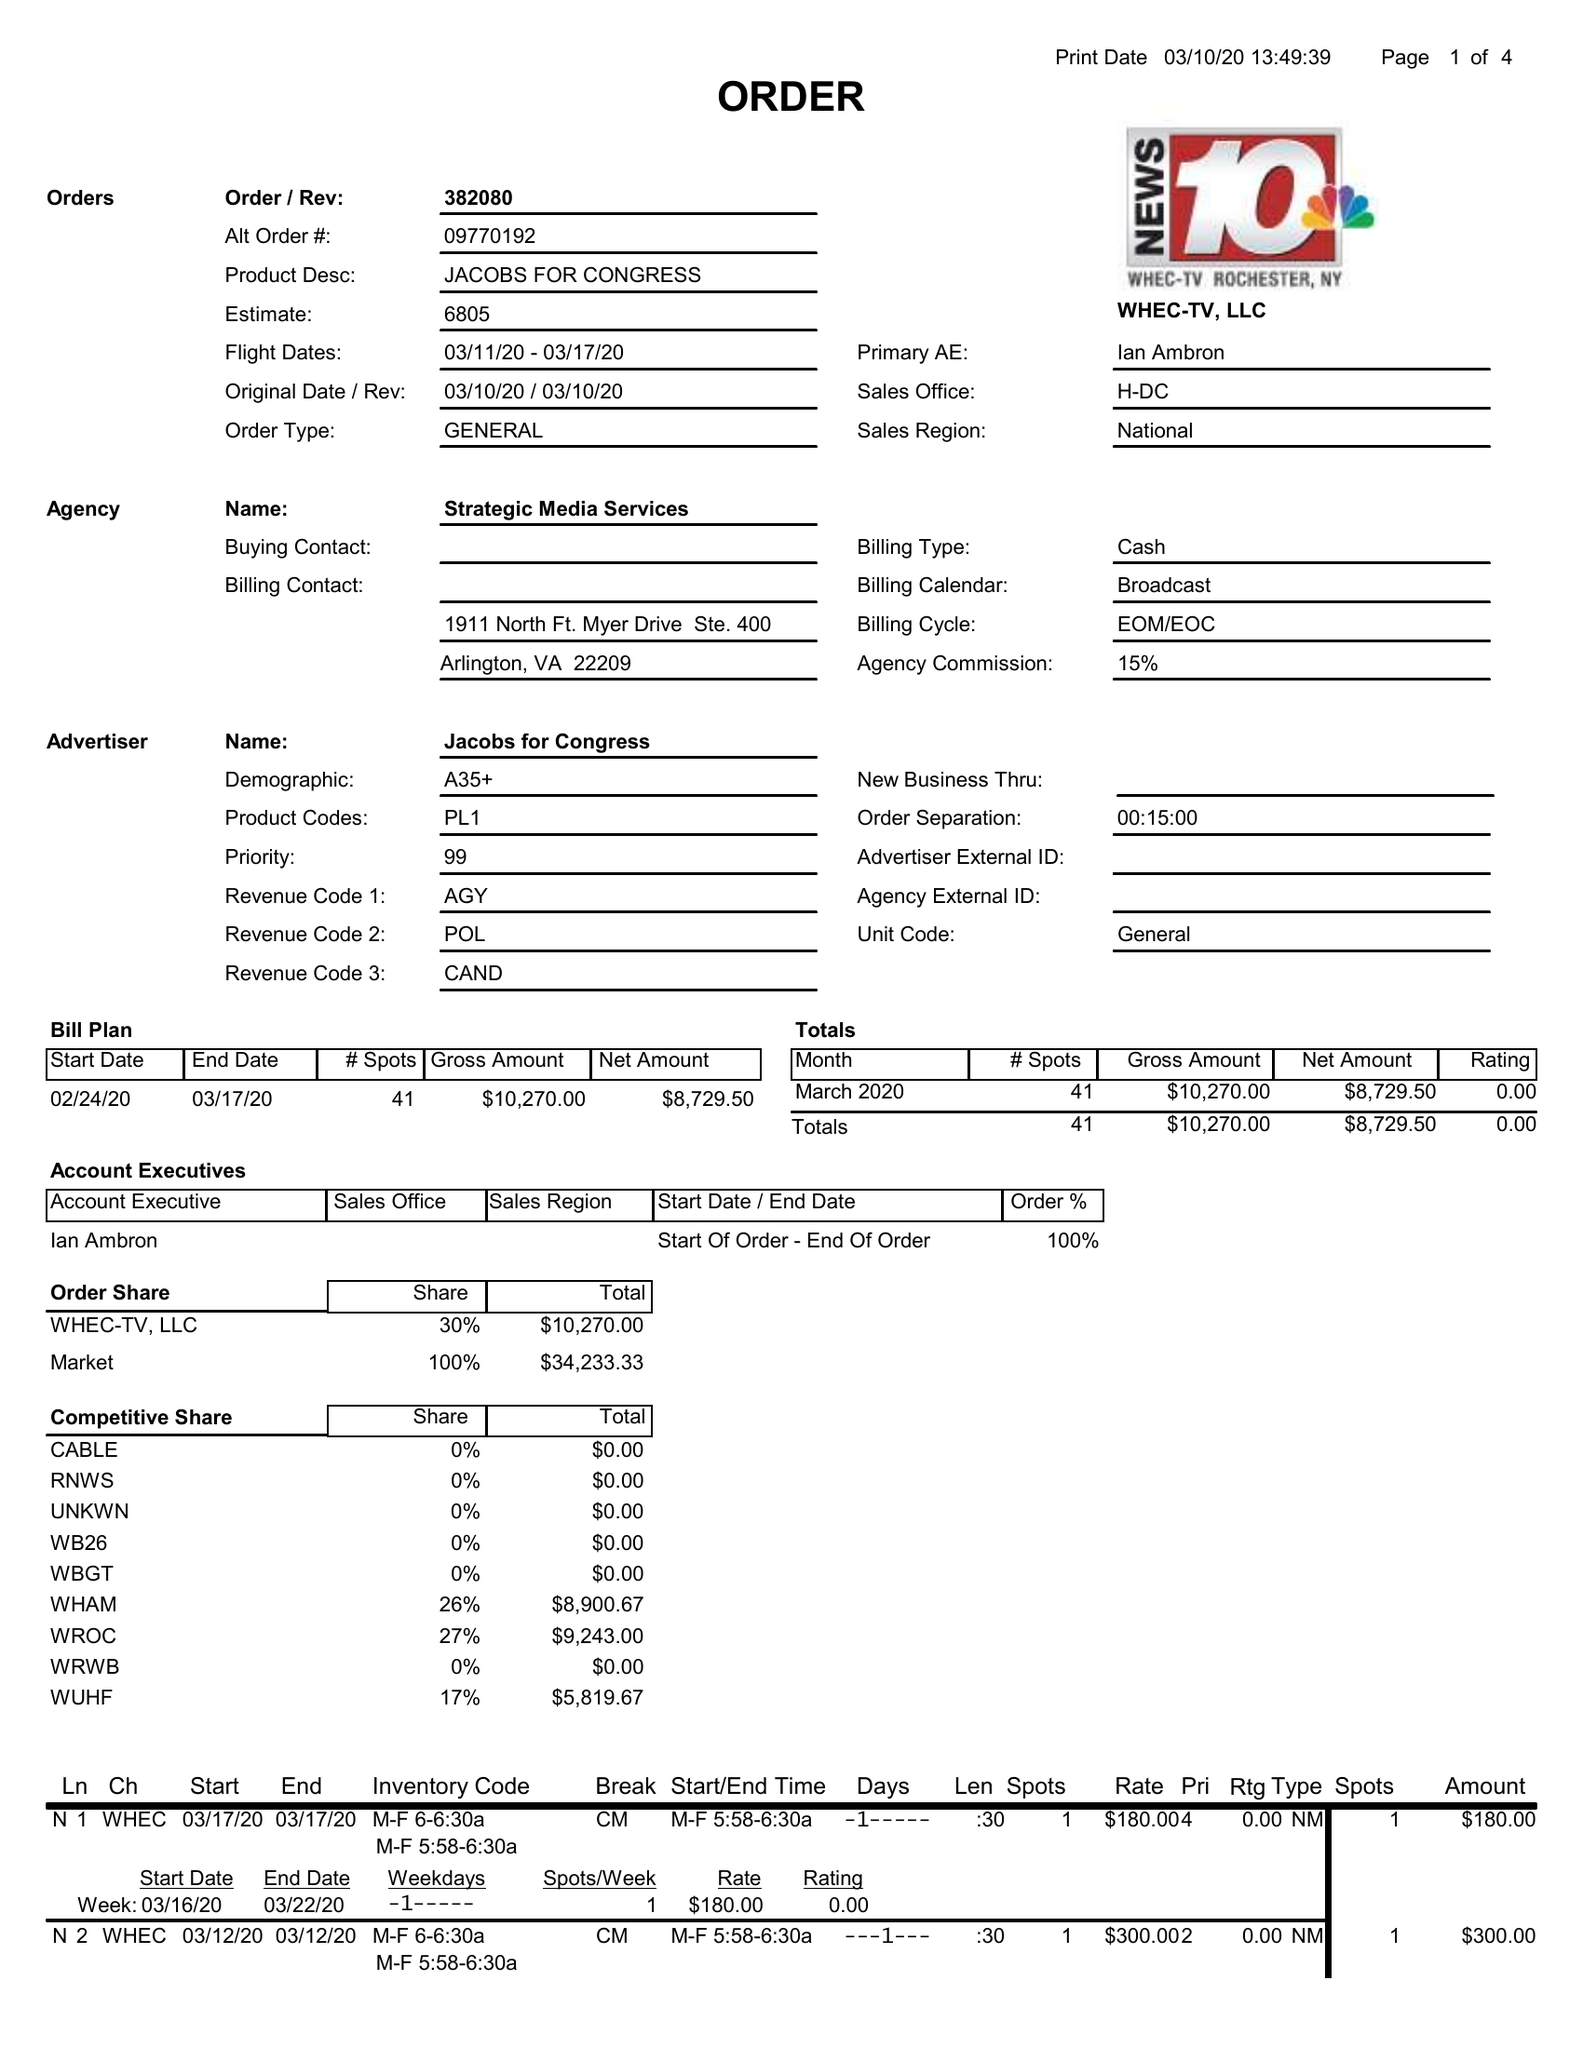What is the value for the advertiser?
Answer the question using a single word or phrase. JACOBS FOR CONGRESS 